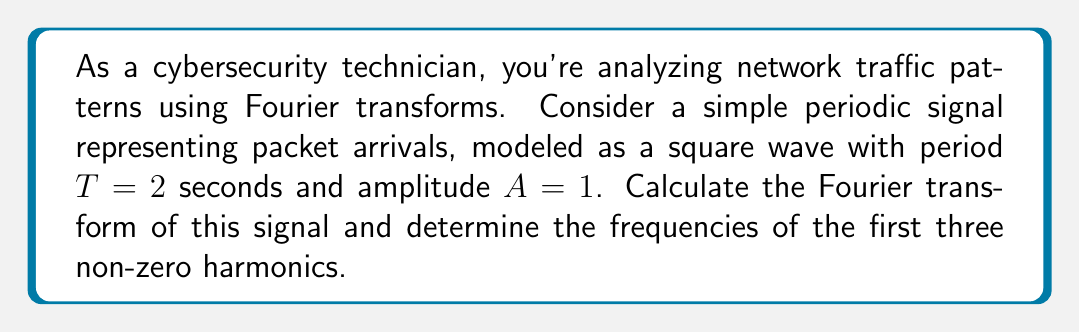Help me with this question. Let's approach this step-by-step:

1) The square wave with period $T$ and amplitude $A$ can be represented by the Fourier series:

   $$f(t) = \frac{4A}{\pi} \sum_{n=1,3,5,...}^{\infty} \frac{1}{n} \sin\left(\frac{2\pi n t}{T}\right)$$

2) For our case, $A=1$ and $T=2$, so:

   $$f(t) = \frac{4}{\pi} \sum_{n=1,3,5,...}^{\infty} \frac{1}{n} \sin\left(\pi n t\right)$$

3) The Fourier transform of a periodic signal is a series of impulses at the frequencies of the harmonics. The amplitude of each impulse is given by the coefficient of the corresponding term in the Fourier series.

4) The Fourier transform of $f(t)$ is:

   $$F(\omega) = 2\pi \sum_{n=1,3,5,...}^{\infty} \frac{2}{\pi n} [\delta(\omega - \pi n) - \delta(\omega + \pi n)]$$

5) The frequencies of the harmonics are given by $\omega_n = \frac{2\pi n}{T} = \pi n$ rad/s.

6) Converting to Hz: $f_n = \frac{\omega_n}{2\pi} = \frac{n}{2}$ Hz

7) The first three non-zero harmonics correspond to $n=1, 3, 5$:
   - First harmonic: $f_1 = 0.5$ Hz
   - Second harmonic: $f_3 = 1.5$ Hz
   - Third harmonic: $f_5 = 2.5$ Hz

These frequencies represent the most significant components of the packet arrival pattern in the frequency domain.
Answer: The Fourier transform of the signal is:
$$F(\omega) = 2\pi \sum_{n=1,3,5,...}^{\infty} \frac{2}{\pi n} [\delta(\omega - \pi n) - \delta(\omega + \pi n)]$$

The frequencies of the first three non-zero harmonics are:
1. 0.5 Hz
2. 1.5 Hz
3. 2.5 Hz 